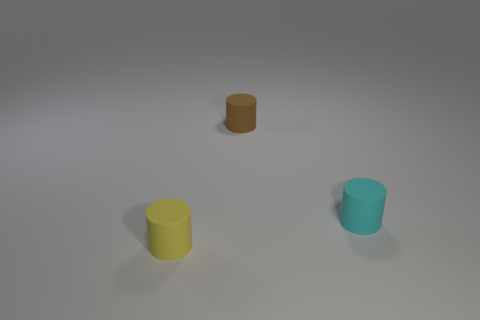What number of objects are tiny blue rubber things or cylinders?
Your response must be concise. 3. How many other objects are the same shape as the cyan thing?
Give a very brief answer. 2. Is the yellow cylinder that is to the left of the brown cylinder made of the same material as the tiny cylinder that is behind the cyan thing?
Provide a short and direct response. Yes. There is a object that is in front of the tiny brown matte object and left of the cyan matte cylinder; what shape is it?
Keep it short and to the point. Cylinder. Are there any other things that are the same material as the small cyan thing?
Offer a terse response. Yes. There is a small thing that is both behind the yellow matte cylinder and in front of the tiny brown thing; what material is it?
Give a very brief answer. Rubber. Are there more yellow cylinders that are in front of the tiny cyan thing than matte cylinders?
Provide a succinct answer. No. What material is the cyan thing?
Give a very brief answer. Rubber. What number of cyan cylinders have the same size as the cyan matte object?
Keep it short and to the point. 0. Are there an equal number of small yellow rubber cylinders left of the small yellow cylinder and tiny cyan matte objects that are behind the brown cylinder?
Provide a short and direct response. Yes. 